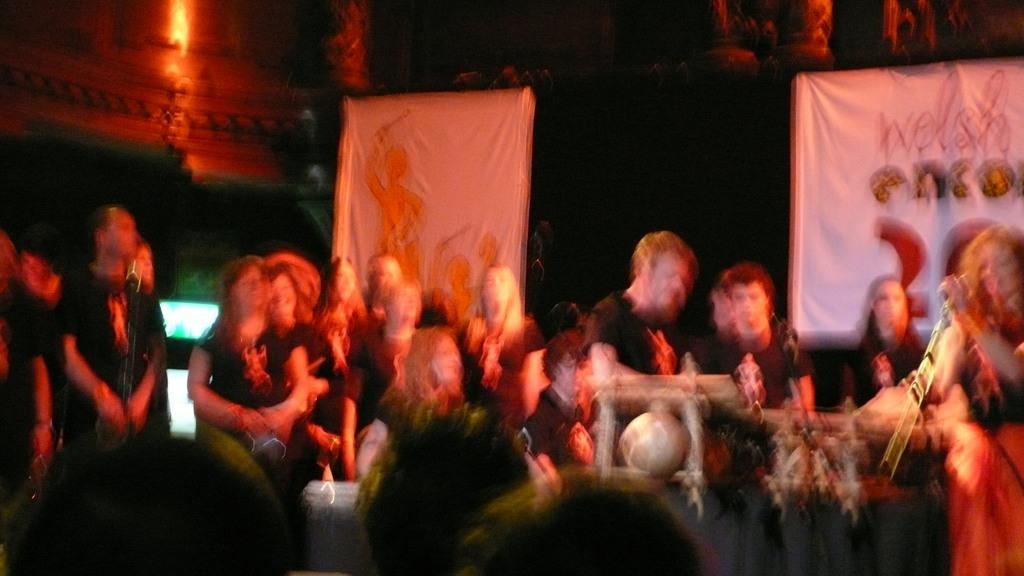What are the people in the image doing? The people in the center of the image are standing. What objects are present that might be related to the people's activity? There are musical instruments and microphones in the image. What can be seen in the background of the image? There are boards visible in the background. What is the composition of the crowd at the bottom of the image? There is a crowd at the bottom of the image. What type of feast is being prepared in the image? There is no indication of a feast being prepared in the image. What force is being exerted on the musical instruments in the image? There is no force being exerted on the musical instruments in the image; they are stationary. 